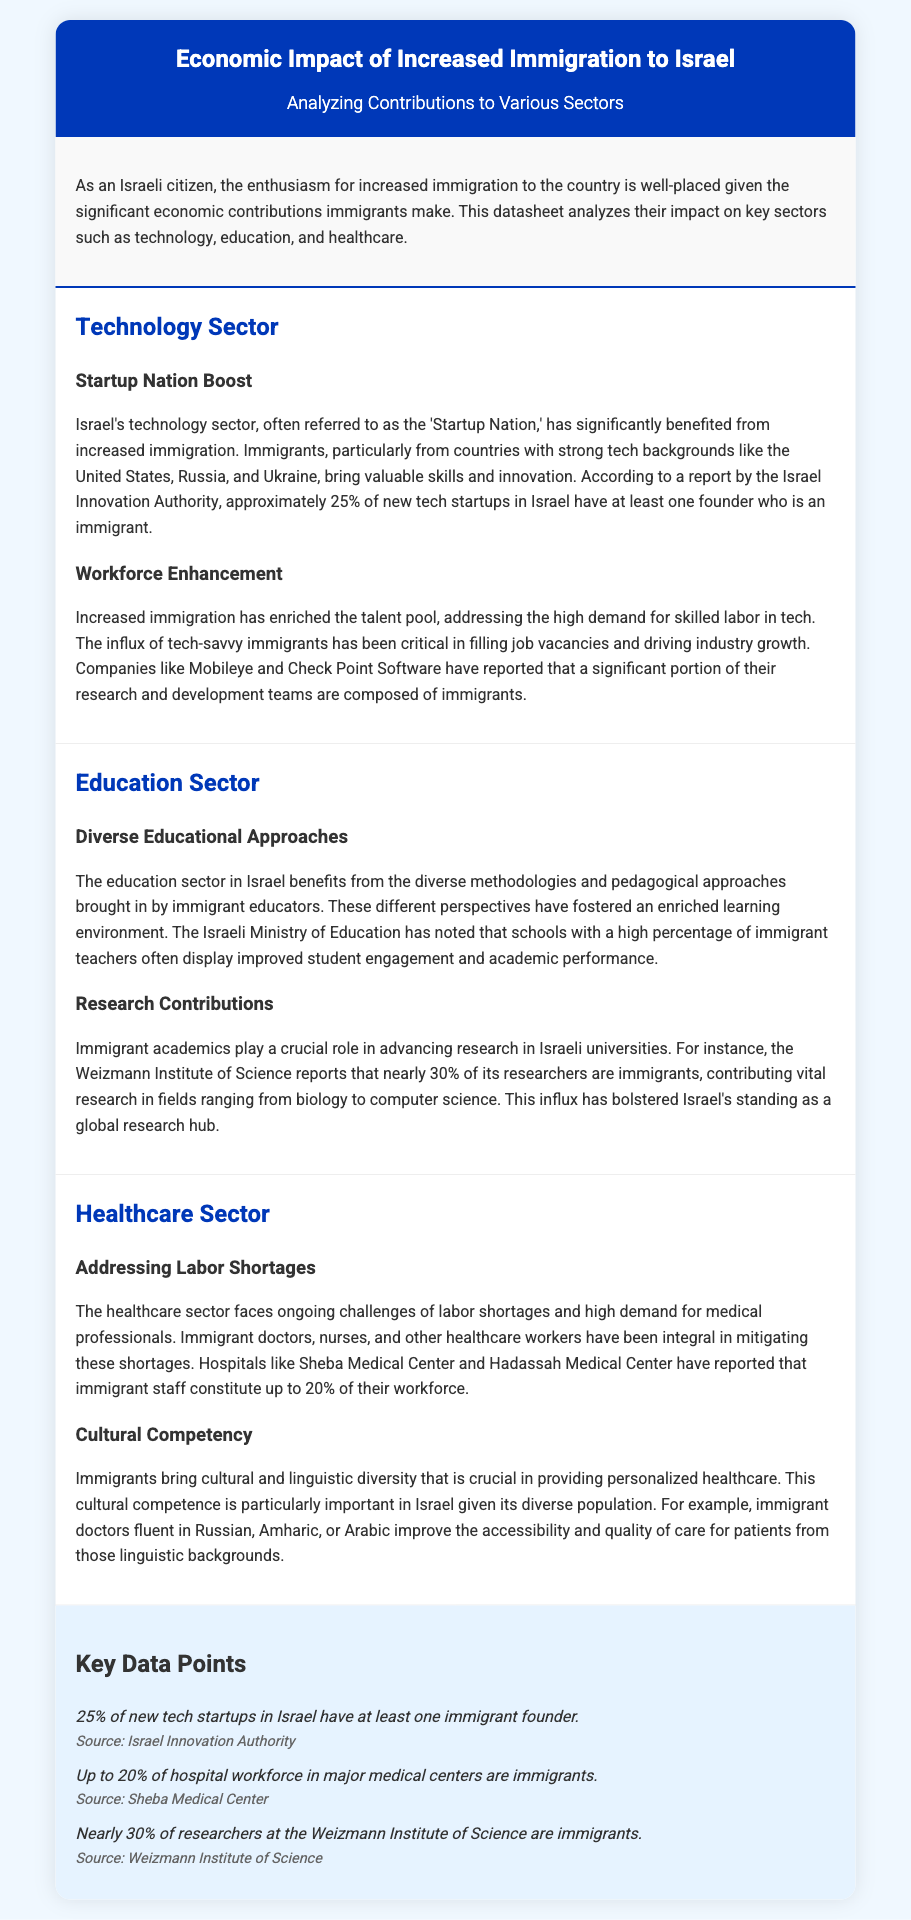What percentage of new tech startups in Israel have at least one immigrant founder? The document states that approximately 25% of new tech startups in Israel have at least one founder who is an immigrant.
Answer: 25% What is the percentage of immigrant researchers at the Weizmann Institute of Science? The document reports that nearly 30% of researchers at the Weizmann Institute of Science are immigrants.
Answer: 30% How much of the workforce in major medical centers is made up of immigrants? According to the document, up to 20% of the hospital workforce in major medical centers are immigrants.
Answer: 20% What significant contribution do immigrant academics provide in the education sector? Immigrant academics advance research in Israeli universities, contributing vital research in various fields.
Answer: Research contributions Which countries are mentioned as sources of skilled tech immigrants? The document mentions the United States, Russia, and Ukraine as countries contributing skilled tech immigrants.
Answer: United States, Russia, Ukraine What role do immigrants play in addressing challenges within the healthcare sector? Immigrants help mitigate labor shortages and provide cultural competency in the healthcare sector.
Answer: Labor shortages How do immigrant educators impact the education sector? The document indicates that diverse methodologies from immigrant educators foster an enriched learning environment.
Answer: Enriched learning What is one advantage of having immigrant doctors in Israel? Immigrant doctors fluent in various languages improve accessibility and quality of care for diverse patients.
Answer: Cultural competence 